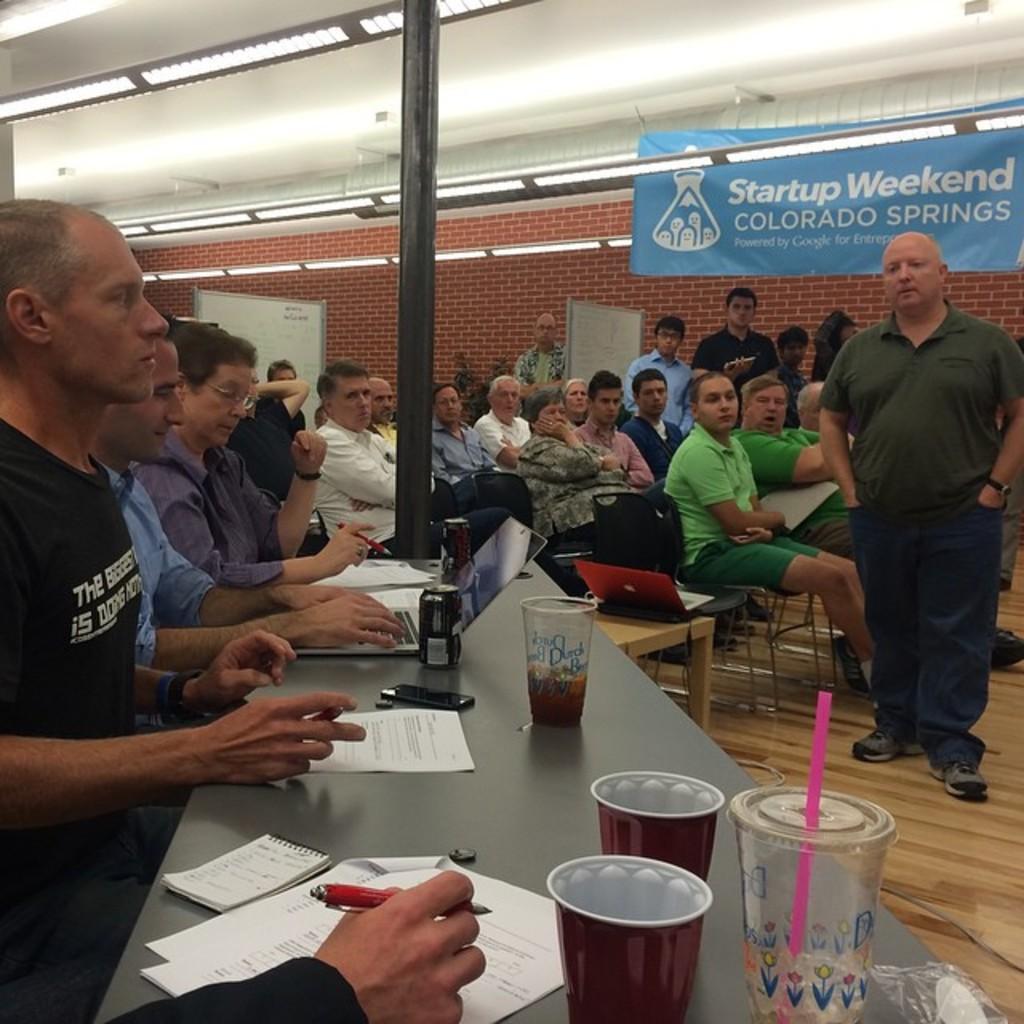In one or two sentences, can you explain what this image depicts? In this picture there is a group of persons On the right side there is a person who is standing and looking to the table. On the left side there is an another person looking at the right person. Most of peoples are sitting on a chair. On this table there is a laptop. On the right side we can see a banner and reads that startup weekend. On the right there is a light and on this table. On the right side On the right side glass and straw. This woman holding a pen. And here it's a mobile and table. 